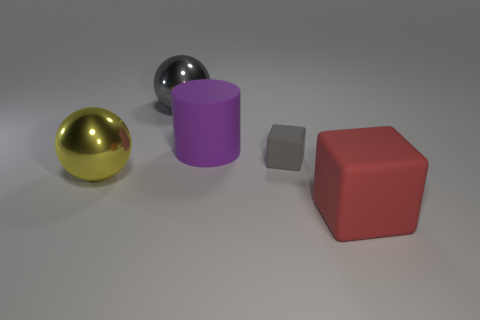Is the color of the metallic ball that is behind the yellow sphere the same as the matte block behind the big red matte thing?
Keep it short and to the point. Yes. What shape is the thing that is the same color as the small matte cube?
Make the answer very short. Sphere. There is a gray block that is made of the same material as the purple thing; what is its size?
Your response must be concise. Small. There is a thing that is in front of the large purple rubber object and behind the large yellow metallic ball; what shape is it?
Offer a very short reply. Cube. Are there the same number of red matte blocks on the left side of the large rubber block and large matte cubes?
Provide a succinct answer. No. How many things are either large purple matte things or large red rubber cubes that are on the right side of the large gray object?
Your answer should be very brief. 2. Is there another tiny object that has the same shape as the purple thing?
Keep it short and to the point. No. Are there the same number of red rubber things that are behind the big purple matte cylinder and large yellow objects to the left of the yellow shiny sphere?
Your answer should be very brief. Yes. Is there anything else that is the same size as the purple cylinder?
Your response must be concise. Yes. How many cyan objects are either large objects or matte blocks?
Offer a very short reply. 0. 